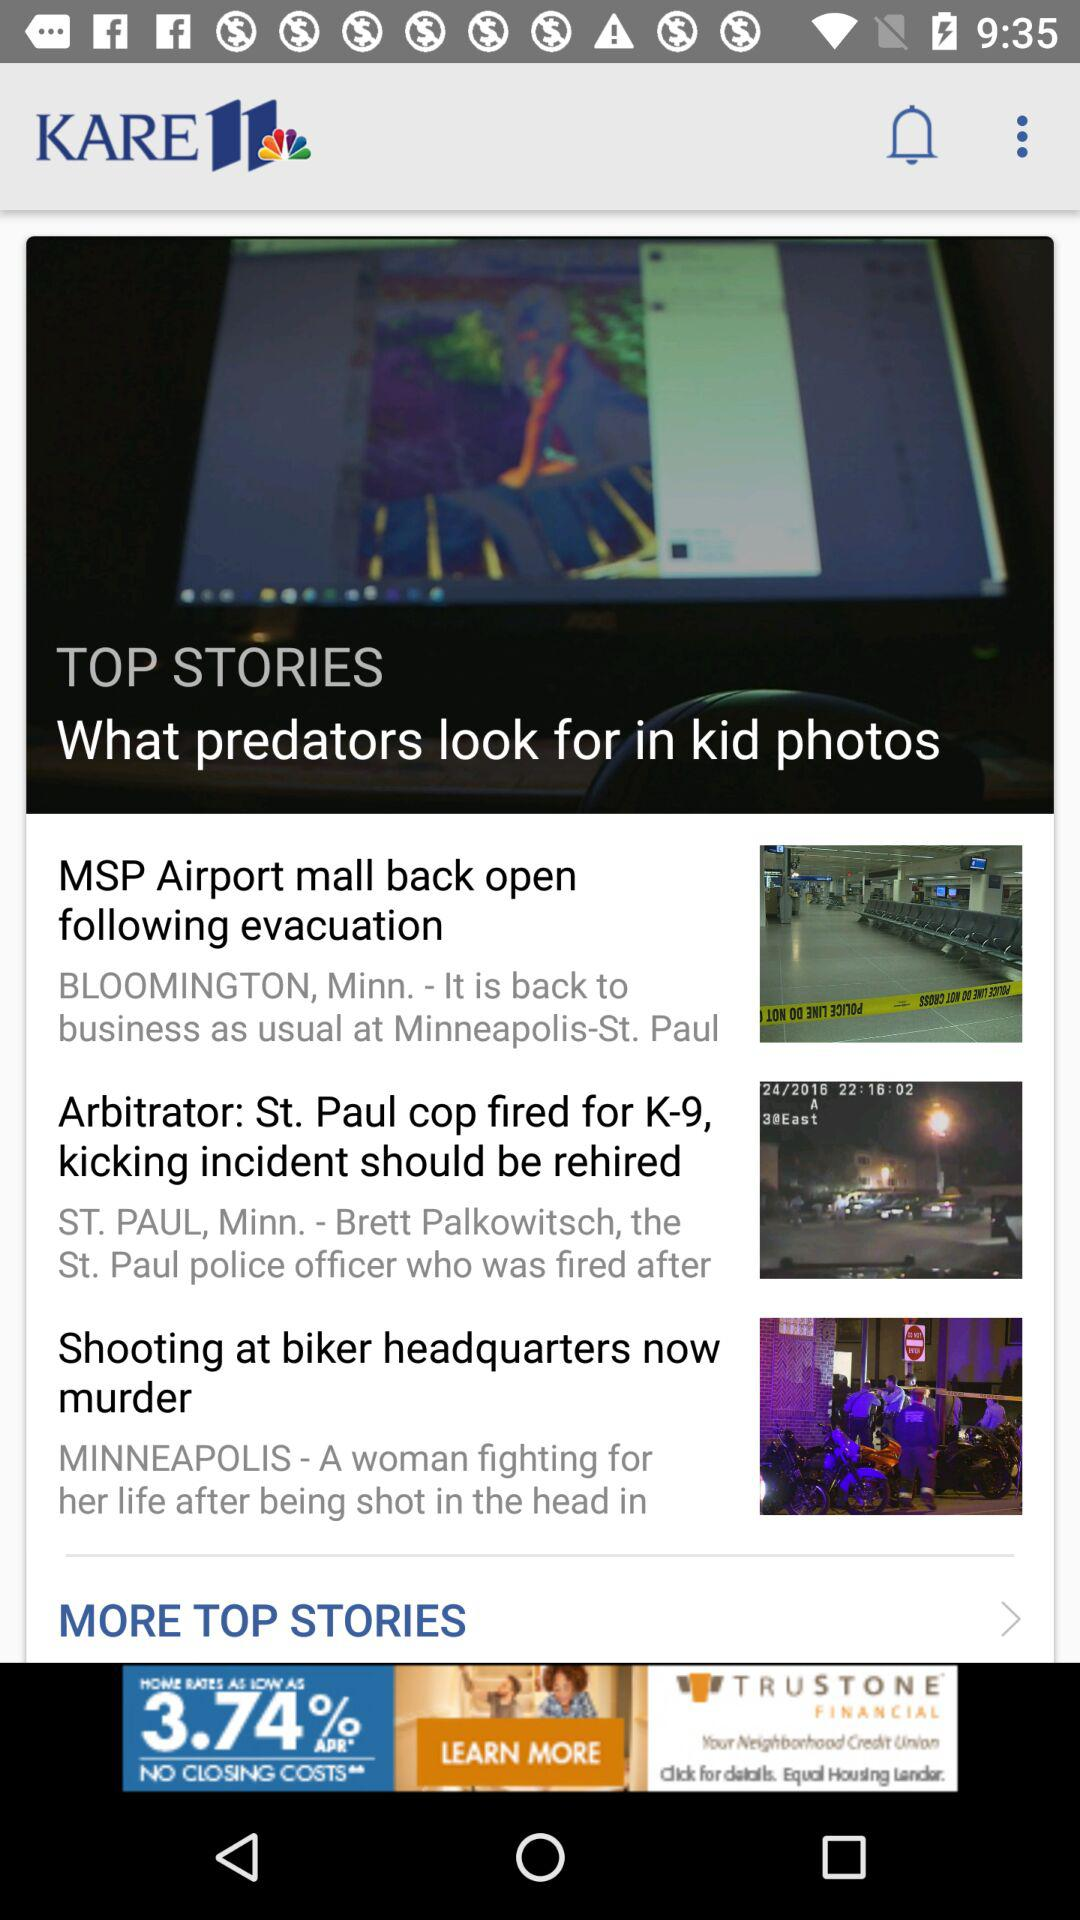How many stories are about the MSP Airport?
Answer the question using a single word or phrase. 1 